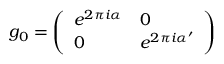<formula> <loc_0><loc_0><loc_500><loc_500>g _ { 0 } = { \left ( \begin{array} { l l } { e ^ { 2 \pi i \alpha } } & { 0 } \\ { 0 } & { e ^ { 2 \pi i \alpha ^ { \prime } } } \end{array} \right ) } \,</formula> 